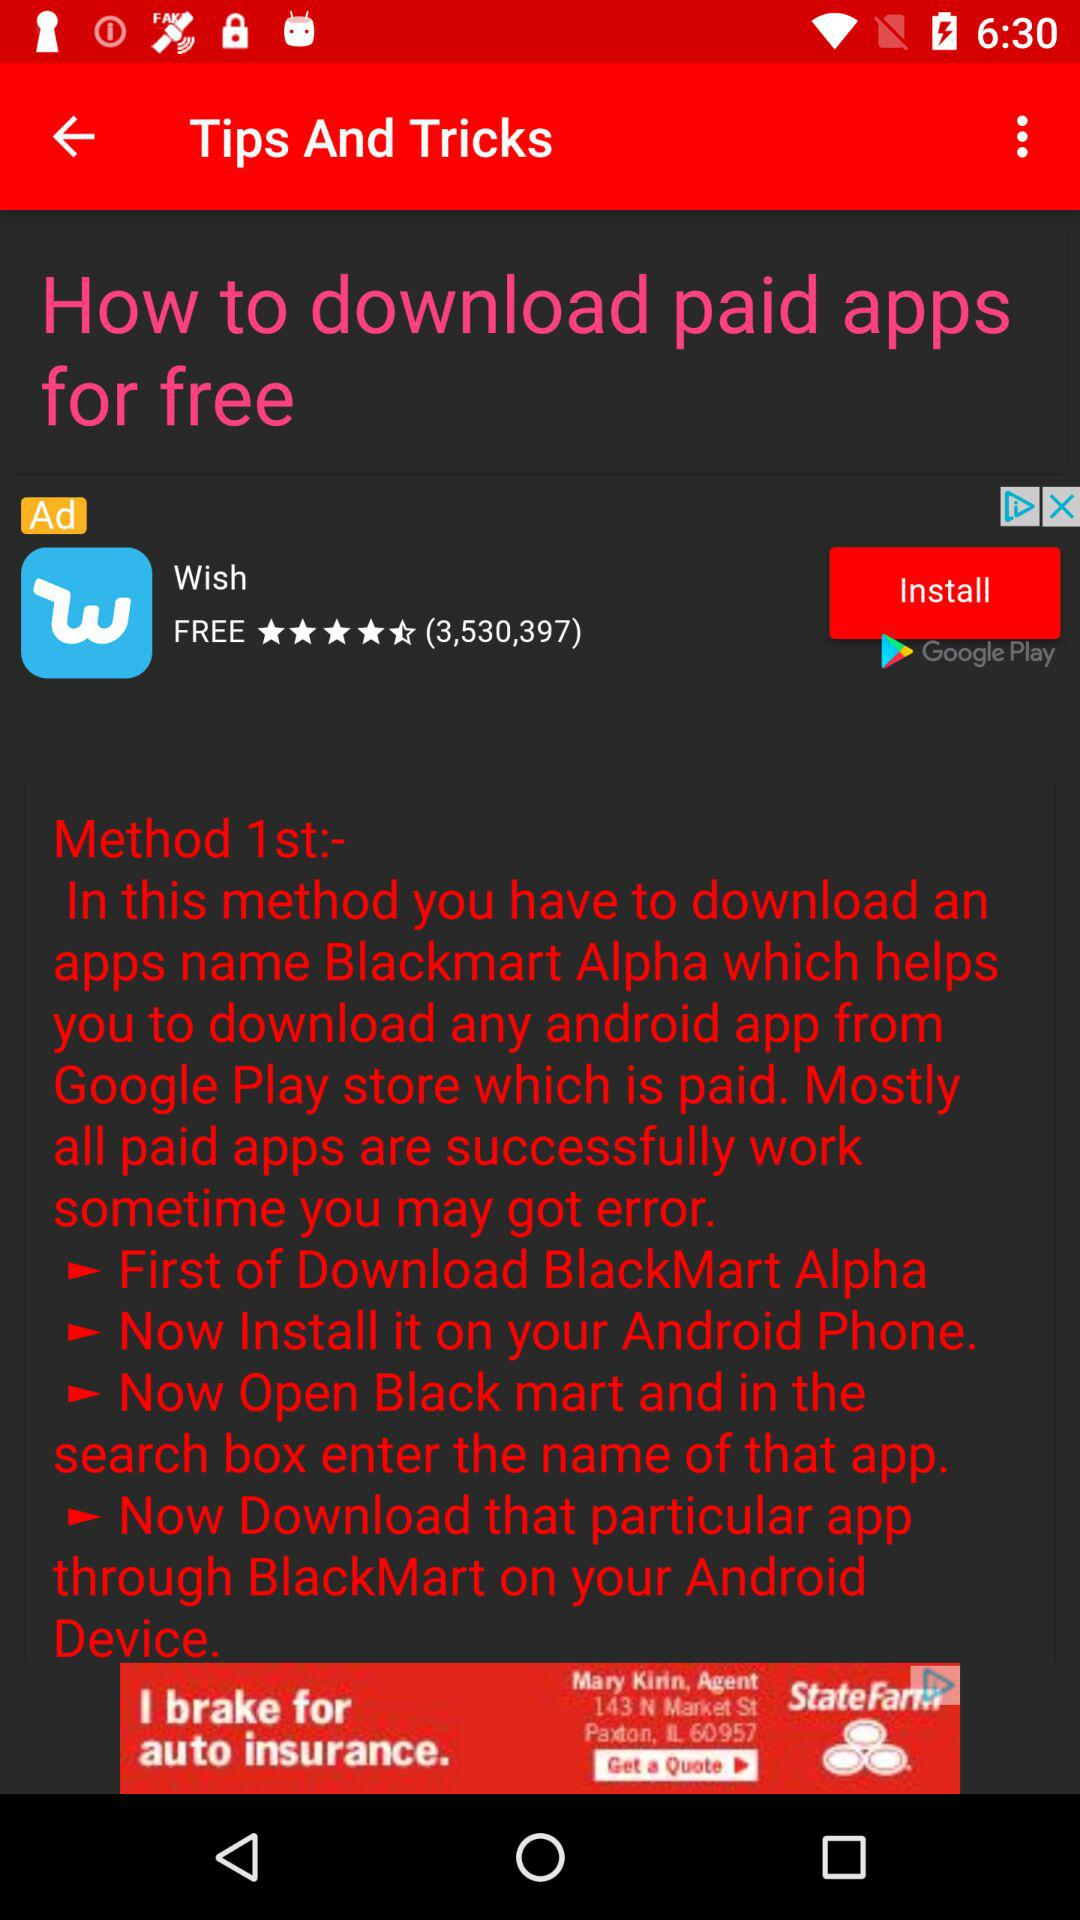What is the name of the application to download any Android paid app from "Google Play store"? The name of the application is "Blackmart Alpha". 